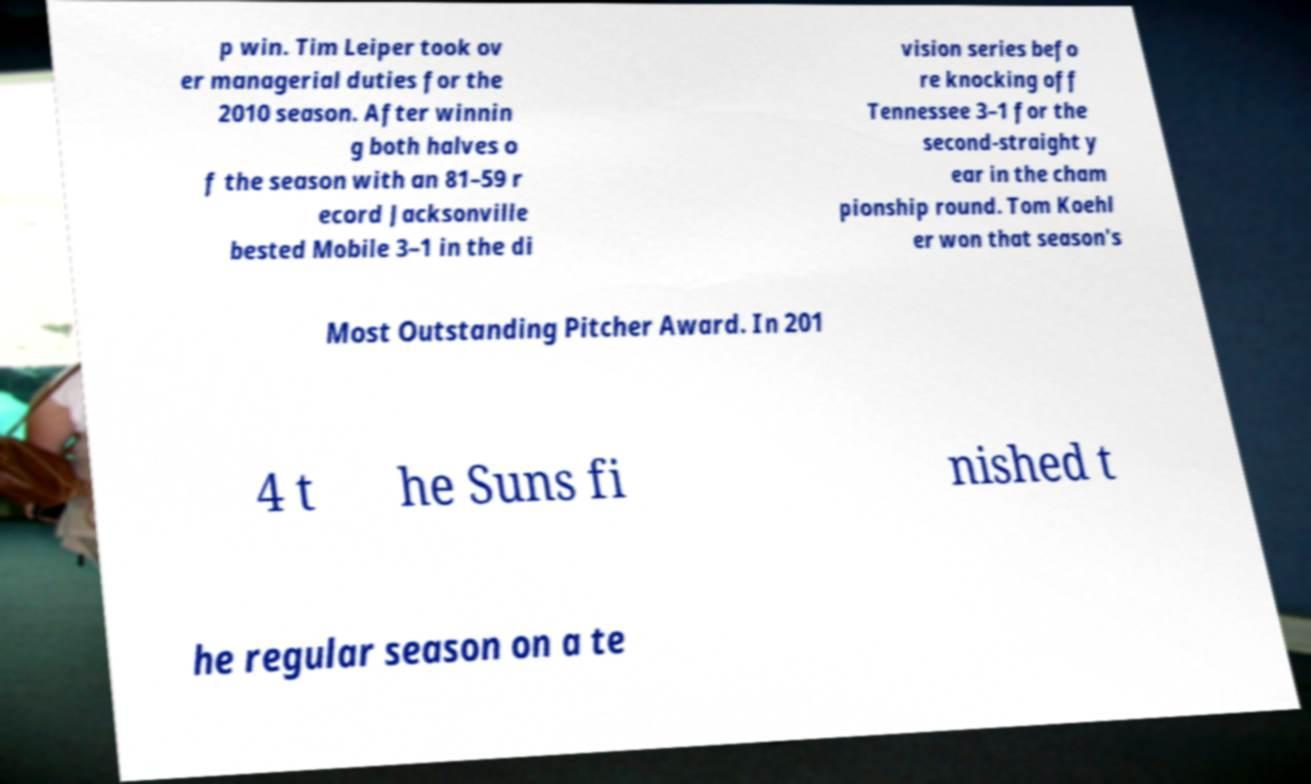What messages or text are displayed in this image? I need them in a readable, typed format. p win. Tim Leiper took ov er managerial duties for the 2010 season. After winnin g both halves o f the season with an 81–59 r ecord Jacksonville bested Mobile 3–1 in the di vision series befo re knocking off Tennessee 3–1 for the second-straight y ear in the cham pionship round. Tom Koehl er won that season's Most Outstanding Pitcher Award. In 201 4 t he Suns fi nished t he regular season on a te 